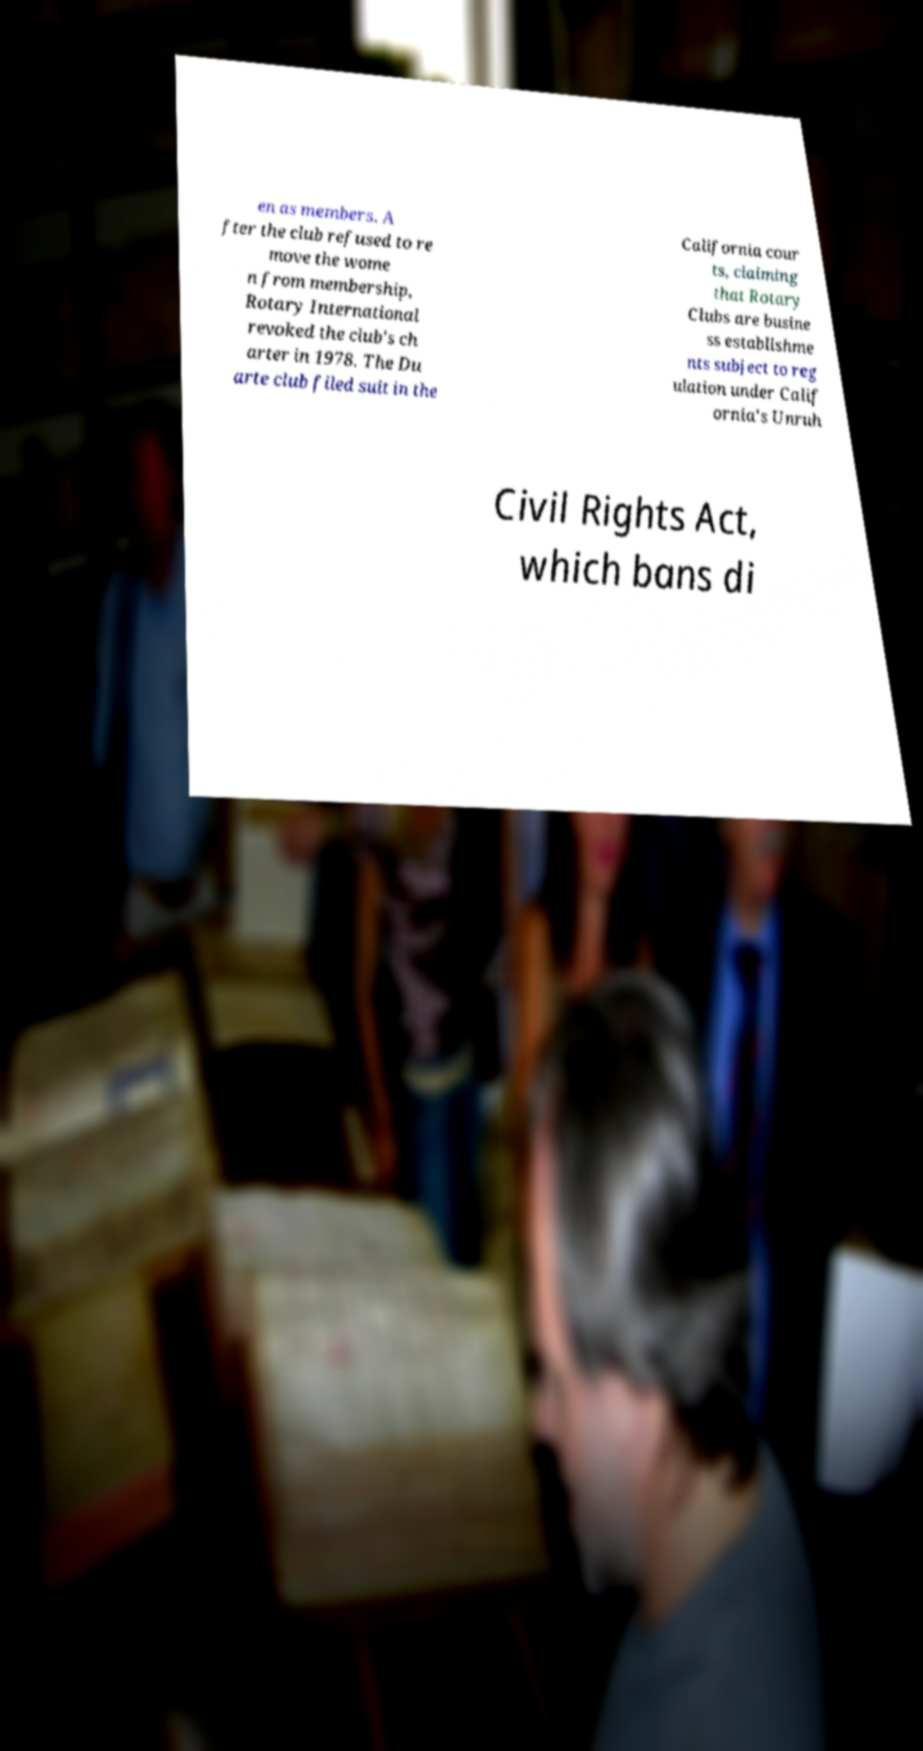Could you extract and type out the text from this image? en as members. A fter the club refused to re move the wome n from membership, Rotary International revoked the club's ch arter in 1978. The Du arte club filed suit in the California cour ts, claiming that Rotary Clubs are busine ss establishme nts subject to reg ulation under Calif ornia's Unruh Civil Rights Act, which bans di 